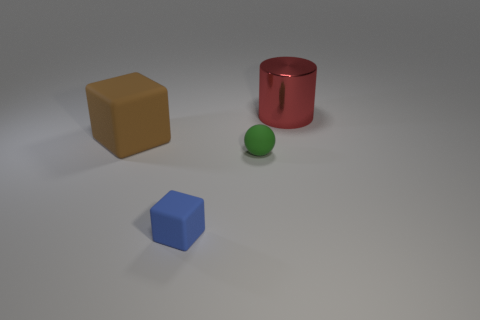What can you infer about the texture of the surface these objects are on? The surface appears smooth and even, with a matte finish that softly diffuses light. There are no visible grains or roughness, which would indicate a polished or synthetic material. 